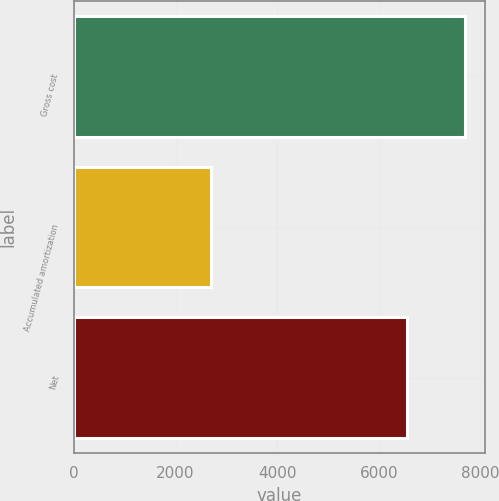Convert chart. <chart><loc_0><loc_0><loc_500><loc_500><bar_chart><fcel>Gross cost<fcel>Accumulated amortization<fcel>Net<nl><fcel>7700<fcel>2695<fcel>6545<nl></chart> 